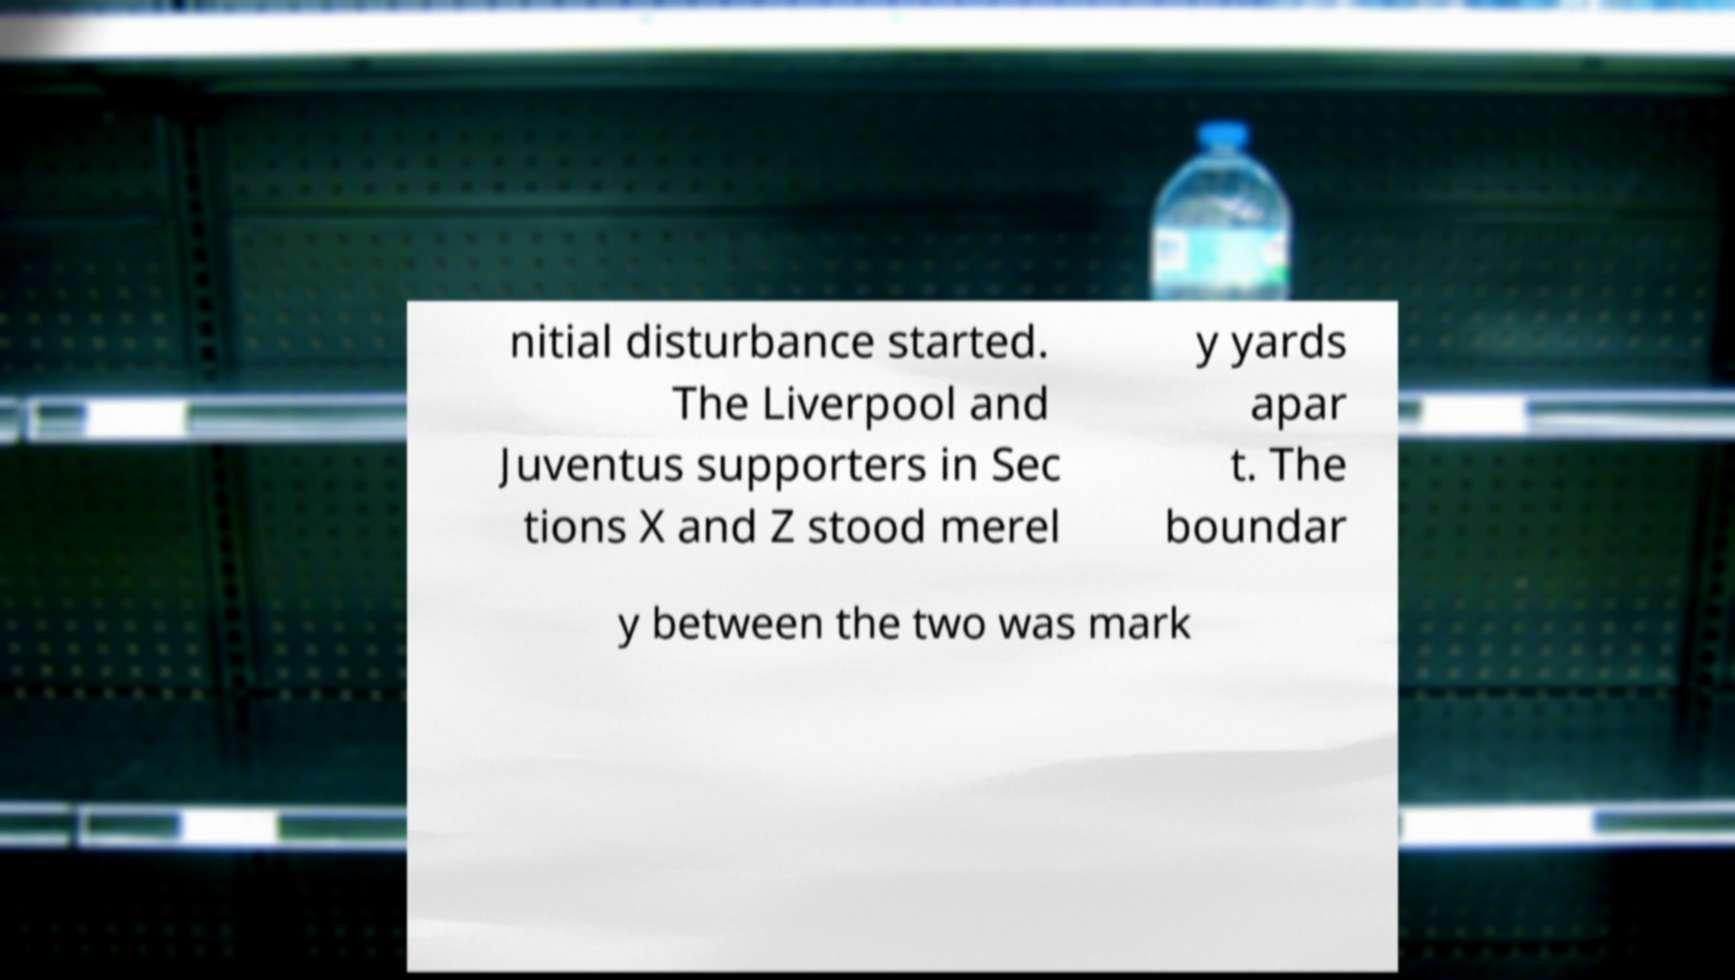What messages or text are displayed in this image? I need them in a readable, typed format. nitial disturbance started. The Liverpool and Juventus supporters in Sec tions X and Z stood merel y yards apar t. The boundar y between the two was mark 